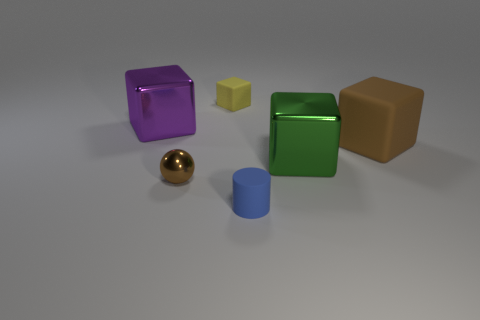Subtract all large purple metal blocks. How many blocks are left? 3 Subtract all brown blocks. How many blocks are left? 3 Subtract all red spheres. Subtract all blue cylinders. How many spheres are left? 1 Subtract all cyan spheres. How many cyan cylinders are left? 0 Subtract all purple metallic cubes. Subtract all rubber objects. How many objects are left? 2 Add 3 brown matte blocks. How many brown matte blocks are left? 4 Add 6 brown objects. How many brown objects exist? 8 Add 1 cyan objects. How many objects exist? 7 Subtract 0 gray cubes. How many objects are left? 6 Subtract all cubes. How many objects are left? 2 